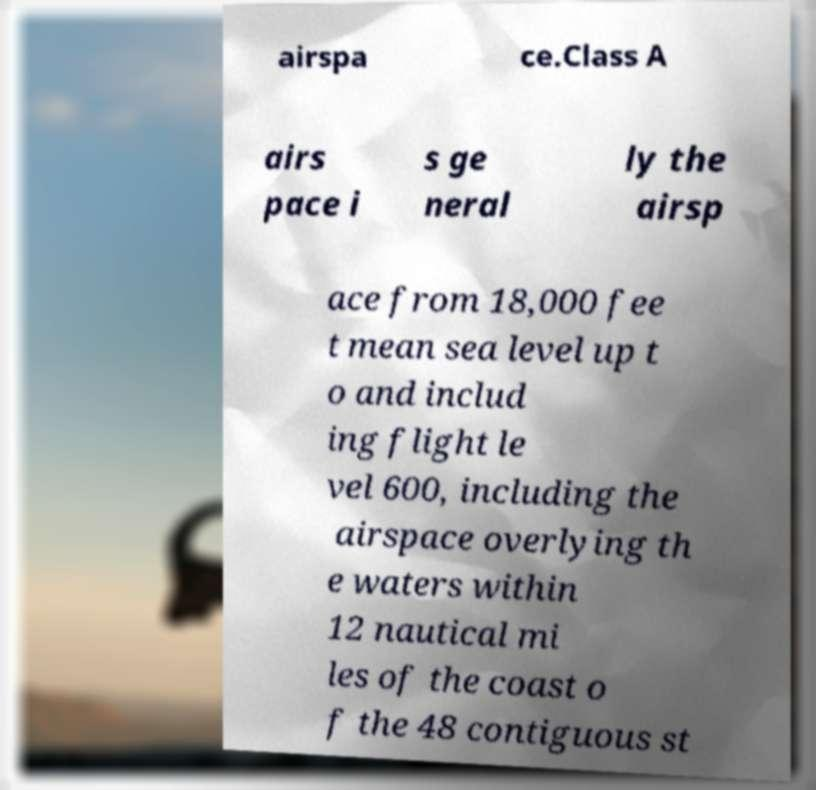Can you read and provide the text displayed in the image?This photo seems to have some interesting text. Can you extract and type it out for me? airspa ce.Class A airs pace i s ge neral ly the airsp ace from 18,000 fee t mean sea level up t o and includ ing flight le vel 600, including the airspace overlying th e waters within 12 nautical mi les of the coast o f the 48 contiguous st 